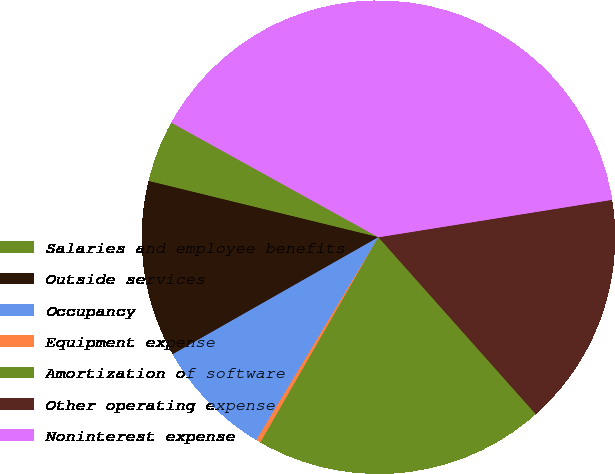Convert chart. <chart><loc_0><loc_0><loc_500><loc_500><pie_chart><fcel>Salaries and employee benefits<fcel>Outside services<fcel>Occupancy<fcel>Equipment expense<fcel>Amortization of software<fcel>Other operating expense<fcel>Noninterest expense<nl><fcel>4.23%<fcel>12.05%<fcel>8.14%<fcel>0.32%<fcel>19.87%<fcel>15.96%<fcel>39.42%<nl></chart> 